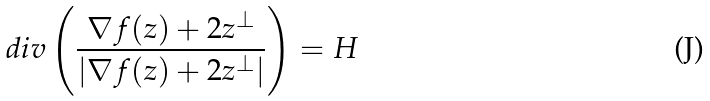Convert formula to latex. <formula><loc_0><loc_0><loc_500><loc_500>d i v \left ( \frac { \nabla f ( z ) + 2 z ^ { \perp } } { | \nabla f ( z ) + 2 z ^ { \perp } | } \right ) = H</formula> 